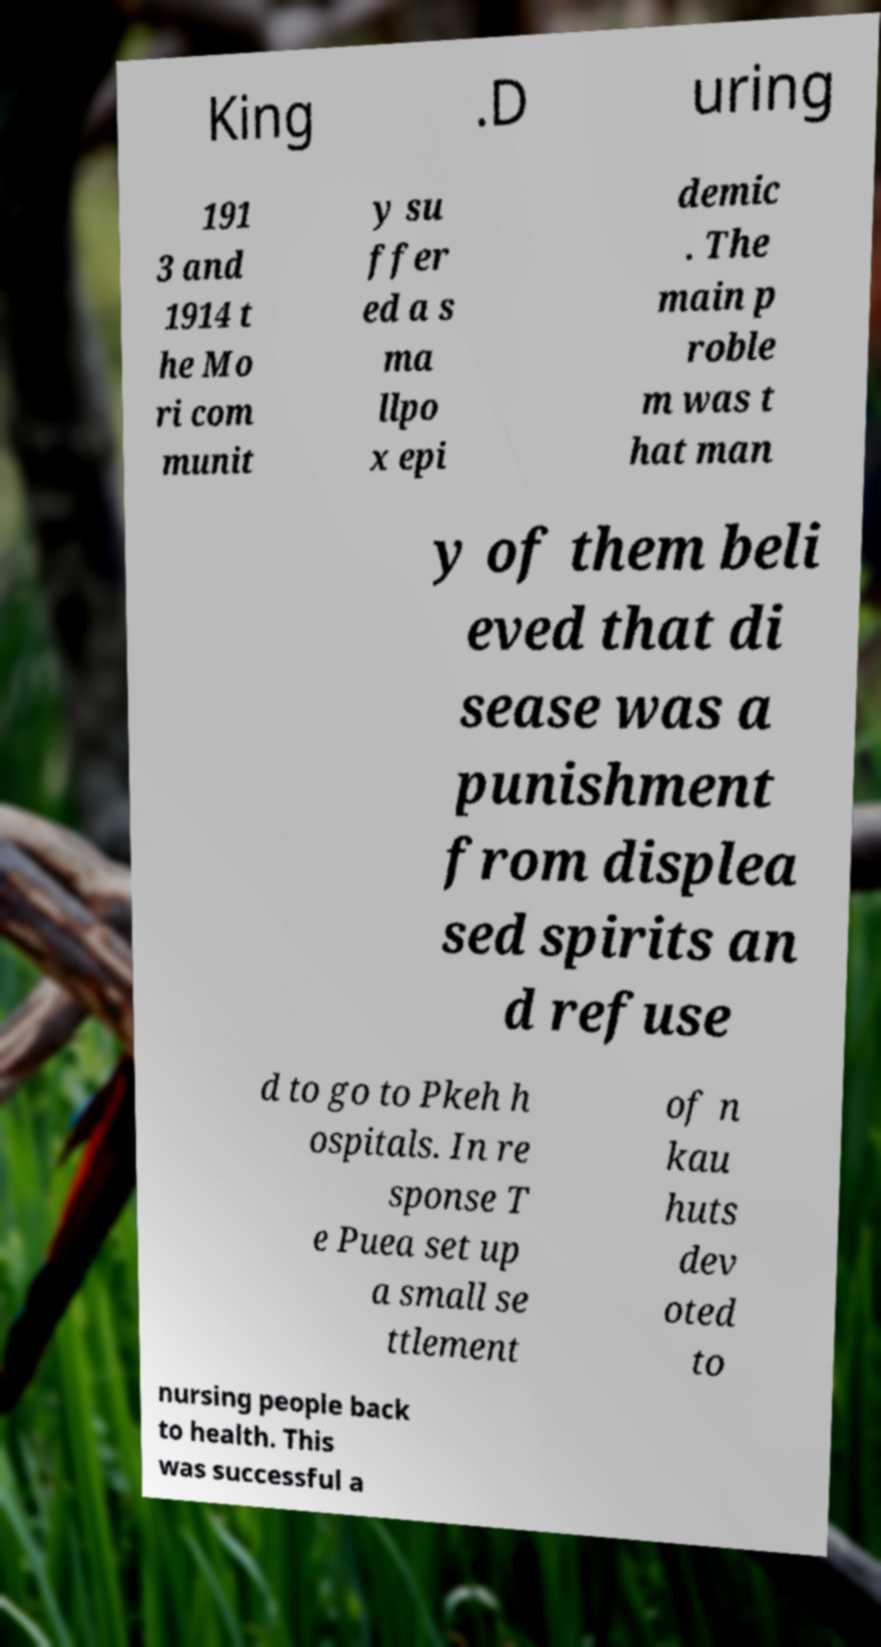There's text embedded in this image that I need extracted. Can you transcribe it verbatim? King .D uring 191 3 and 1914 t he Mo ri com munit y su ffer ed a s ma llpo x epi demic . The main p roble m was t hat man y of them beli eved that di sease was a punishment from displea sed spirits an d refuse d to go to Pkeh h ospitals. In re sponse T e Puea set up a small se ttlement of n kau huts dev oted to nursing people back to health. This was successful a 